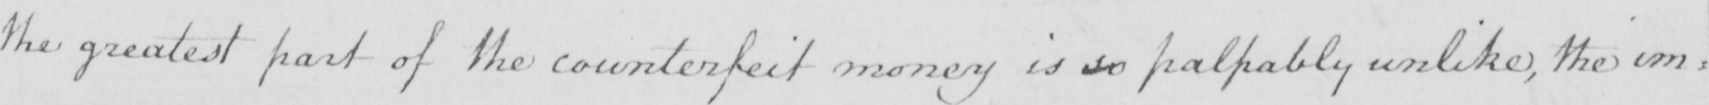Transcribe the text shown in this historical manuscript line. the greatest part of the counterfeit money is so palpably unlike , the im= 